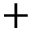Convert formula to latex. <formula><loc_0><loc_0><loc_500><loc_500>+</formula> 